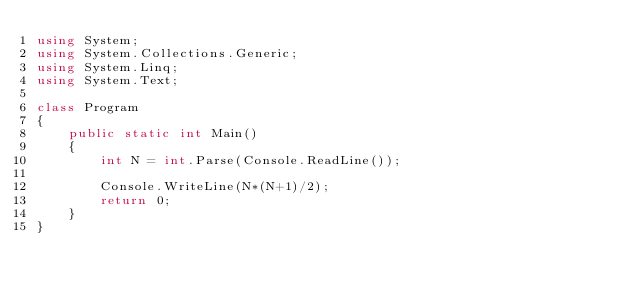<code> <loc_0><loc_0><loc_500><loc_500><_C#_>using System;
using System.Collections.Generic;
using System.Linq;
using System.Text;

class Program
{
    public static int Main()
    {
        int N = int.Parse(Console.ReadLine());

        Console.WriteLine(N*(N+1)/2);
        return 0;
    }
}
</code> 